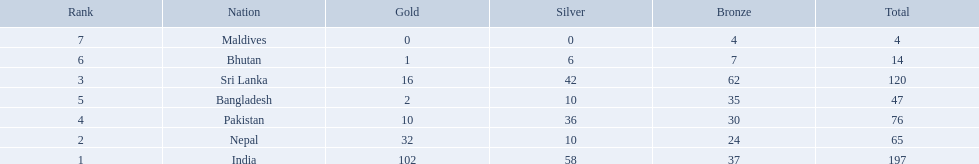Which countries won medals? India, Nepal, Sri Lanka, Pakistan, Bangladesh, Bhutan, Maldives. Which won the most? India. Which won the fewest? Maldives. 